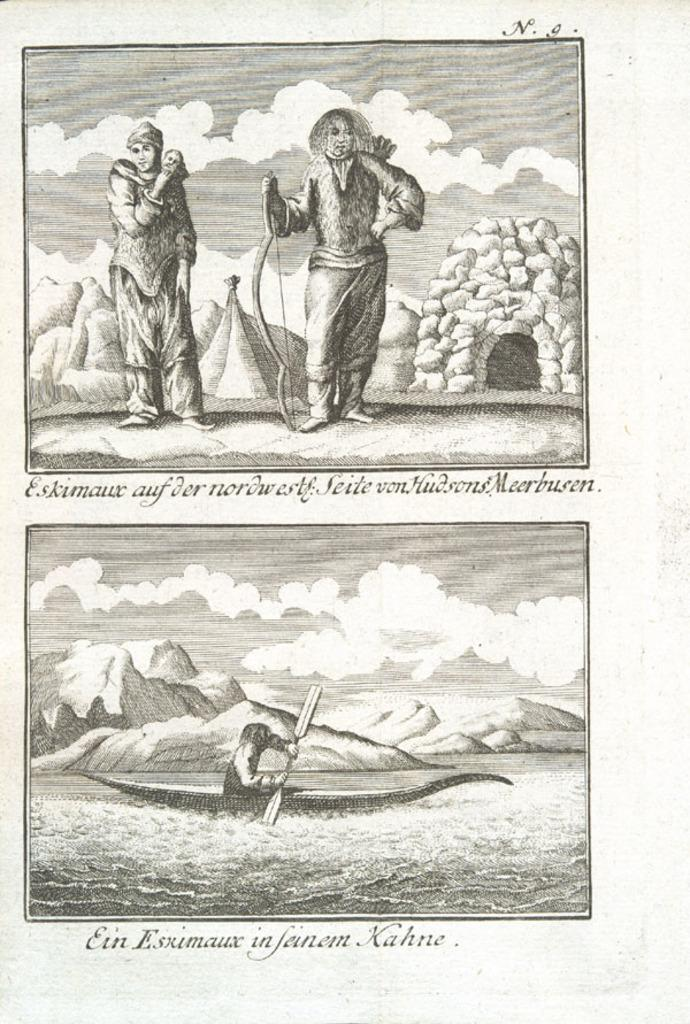What is featured in the image that contains text? There is a poster in the image that contains text. What can be seen in the images of people on the poster? The images of people on the poster are depicted near water and a boat. What natural elements are present on the poster? Water, a boat, the sky, and clouds are present on the poster. What type of experience can be gained by using the scale in the image? There is no scale present in the image, so it is not possible to gain any experience from using it. 